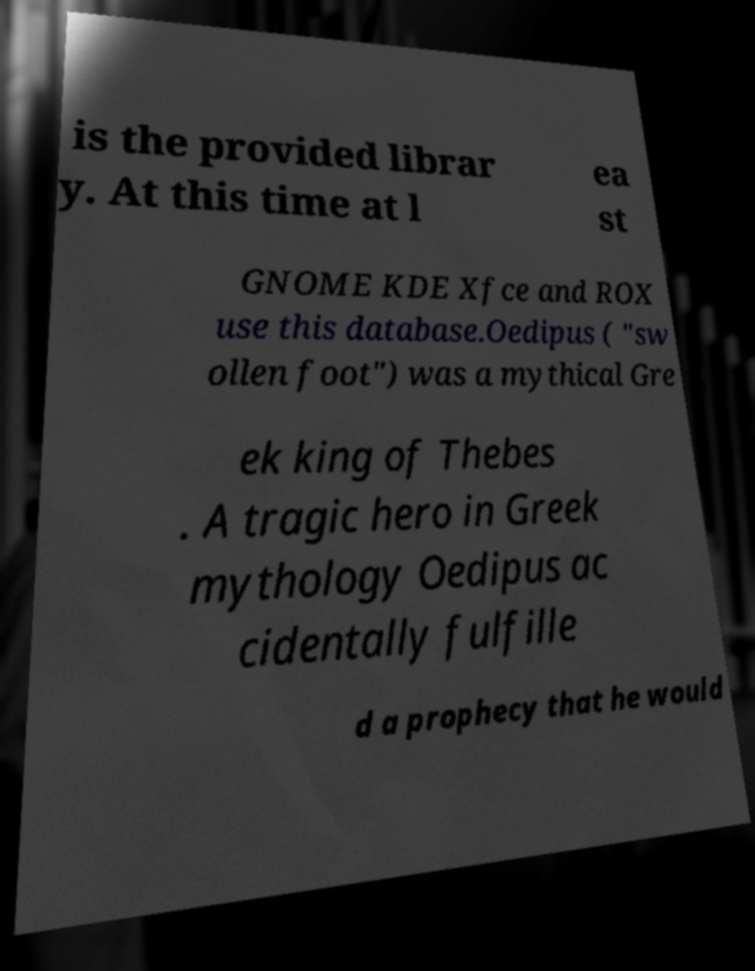Could you assist in decoding the text presented in this image and type it out clearly? is the provided librar y. At this time at l ea st GNOME KDE Xfce and ROX use this database.Oedipus ( "sw ollen foot") was a mythical Gre ek king of Thebes . A tragic hero in Greek mythology Oedipus ac cidentally fulfille d a prophecy that he would 